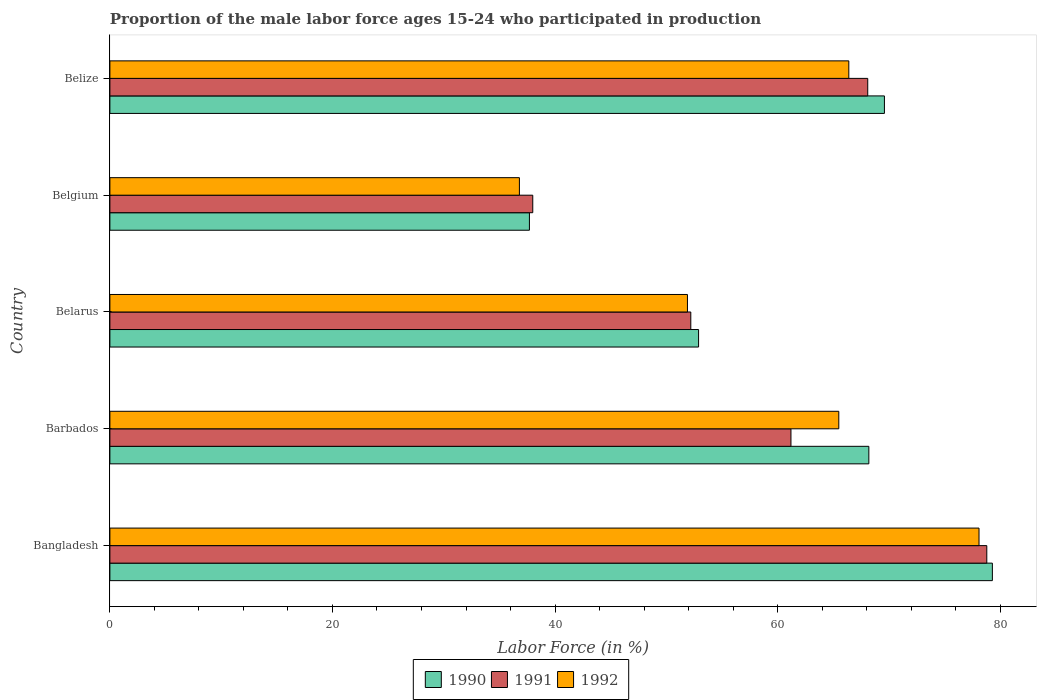How many different coloured bars are there?
Your response must be concise. 3. Are the number of bars per tick equal to the number of legend labels?
Provide a succinct answer. Yes. Are the number of bars on each tick of the Y-axis equal?
Provide a succinct answer. Yes. What is the label of the 3rd group of bars from the top?
Offer a terse response. Belarus. In how many cases, is the number of bars for a given country not equal to the number of legend labels?
Make the answer very short. 0. What is the proportion of the male labor force who participated in production in 1992 in Belize?
Your response must be concise. 66.4. Across all countries, what is the maximum proportion of the male labor force who participated in production in 1990?
Make the answer very short. 79.3. Across all countries, what is the minimum proportion of the male labor force who participated in production in 1991?
Give a very brief answer. 38. In which country was the proportion of the male labor force who participated in production in 1992 maximum?
Provide a succinct answer. Bangladesh. In which country was the proportion of the male labor force who participated in production in 1991 minimum?
Offer a very short reply. Belgium. What is the total proportion of the male labor force who participated in production in 1991 in the graph?
Provide a short and direct response. 298.3. What is the difference between the proportion of the male labor force who participated in production in 1991 in Belgium and that in Belize?
Offer a terse response. -30.1. What is the difference between the proportion of the male labor force who participated in production in 1991 in Bangladesh and the proportion of the male labor force who participated in production in 1990 in Belgium?
Keep it short and to the point. 41.1. What is the average proportion of the male labor force who participated in production in 1991 per country?
Your answer should be compact. 59.66. What is the difference between the proportion of the male labor force who participated in production in 1990 and proportion of the male labor force who participated in production in 1991 in Belgium?
Give a very brief answer. -0.3. In how many countries, is the proportion of the male labor force who participated in production in 1991 greater than 16 %?
Offer a very short reply. 5. What is the ratio of the proportion of the male labor force who participated in production in 1990 in Bangladesh to that in Barbados?
Give a very brief answer. 1.16. Is the proportion of the male labor force who participated in production in 1991 in Belgium less than that in Belize?
Ensure brevity in your answer.  Yes. What is the difference between the highest and the second highest proportion of the male labor force who participated in production in 1991?
Your answer should be compact. 10.7. What is the difference between the highest and the lowest proportion of the male labor force who participated in production in 1990?
Make the answer very short. 41.6. In how many countries, is the proportion of the male labor force who participated in production in 1991 greater than the average proportion of the male labor force who participated in production in 1991 taken over all countries?
Your response must be concise. 3. What does the 3rd bar from the bottom in Belize represents?
Provide a succinct answer. 1992. Is it the case that in every country, the sum of the proportion of the male labor force who participated in production in 1992 and proportion of the male labor force who participated in production in 1991 is greater than the proportion of the male labor force who participated in production in 1990?
Your response must be concise. Yes. How many bars are there?
Your response must be concise. 15. Are all the bars in the graph horizontal?
Make the answer very short. Yes. How many countries are there in the graph?
Give a very brief answer. 5. What is the difference between two consecutive major ticks on the X-axis?
Your answer should be very brief. 20. Are the values on the major ticks of X-axis written in scientific E-notation?
Keep it short and to the point. No. Does the graph contain any zero values?
Your answer should be very brief. No. Where does the legend appear in the graph?
Provide a succinct answer. Bottom center. What is the title of the graph?
Your answer should be very brief. Proportion of the male labor force ages 15-24 who participated in production. Does "1998" appear as one of the legend labels in the graph?
Give a very brief answer. No. What is the label or title of the Y-axis?
Offer a terse response. Country. What is the Labor Force (in %) in 1990 in Bangladesh?
Your answer should be compact. 79.3. What is the Labor Force (in %) in 1991 in Bangladesh?
Provide a succinct answer. 78.8. What is the Labor Force (in %) in 1992 in Bangladesh?
Your response must be concise. 78.1. What is the Labor Force (in %) of 1990 in Barbados?
Your answer should be compact. 68.2. What is the Labor Force (in %) in 1991 in Barbados?
Offer a terse response. 61.2. What is the Labor Force (in %) of 1992 in Barbados?
Your response must be concise. 65.5. What is the Labor Force (in %) in 1990 in Belarus?
Offer a terse response. 52.9. What is the Labor Force (in %) in 1991 in Belarus?
Give a very brief answer. 52.2. What is the Labor Force (in %) of 1992 in Belarus?
Ensure brevity in your answer.  51.9. What is the Labor Force (in %) in 1990 in Belgium?
Give a very brief answer. 37.7. What is the Labor Force (in %) in 1991 in Belgium?
Provide a short and direct response. 38. What is the Labor Force (in %) of 1992 in Belgium?
Offer a very short reply. 36.8. What is the Labor Force (in %) in 1990 in Belize?
Provide a succinct answer. 69.6. What is the Labor Force (in %) of 1991 in Belize?
Ensure brevity in your answer.  68.1. What is the Labor Force (in %) of 1992 in Belize?
Your response must be concise. 66.4. Across all countries, what is the maximum Labor Force (in %) of 1990?
Keep it short and to the point. 79.3. Across all countries, what is the maximum Labor Force (in %) in 1991?
Your answer should be very brief. 78.8. Across all countries, what is the maximum Labor Force (in %) of 1992?
Give a very brief answer. 78.1. Across all countries, what is the minimum Labor Force (in %) in 1990?
Keep it short and to the point. 37.7. Across all countries, what is the minimum Labor Force (in %) of 1992?
Your answer should be very brief. 36.8. What is the total Labor Force (in %) in 1990 in the graph?
Keep it short and to the point. 307.7. What is the total Labor Force (in %) in 1991 in the graph?
Offer a terse response. 298.3. What is the total Labor Force (in %) of 1992 in the graph?
Give a very brief answer. 298.7. What is the difference between the Labor Force (in %) in 1990 in Bangladesh and that in Belarus?
Your answer should be very brief. 26.4. What is the difference between the Labor Force (in %) of 1991 in Bangladesh and that in Belarus?
Make the answer very short. 26.6. What is the difference between the Labor Force (in %) in 1992 in Bangladesh and that in Belarus?
Keep it short and to the point. 26.2. What is the difference between the Labor Force (in %) in 1990 in Bangladesh and that in Belgium?
Give a very brief answer. 41.6. What is the difference between the Labor Force (in %) of 1991 in Bangladesh and that in Belgium?
Ensure brevity in your answer.  40.8. What is the difference between the Labor Force (in %) in 1992 in Bangladesh and that in Belgium?
Your answer should be compact. 41.3. What is the difference between the Labor Force (in %) of 1990 in Bangladesh and that in Belize?
Provide a succinct answer. 9.7. What is the difference between the Labor Force (in %) of 1992 in Bangladesh and that in Belize?
Your response must be concise. 11.7. What is the difference between the Labor Force (in %) of 1990 in Barbados and that in Belarus?
Provide a succinct answer. 15.3. What is the difference between the Labor Force (in %) in 1992 in Barbados and that in Belarus?
Your answer should be very brief. 13.6. What is the difference between the Labor Force (in %) of 1990 in Barbados and that in Belgium?
Offer a terse response. 30.5. What is the difference between the Labor Force (in %) in 1991 in Barbados and that in Belgium?
Provide a short and direct response. 23.2. What is the difference between the Labor Force (in %) of 1992 in Barbados and that in Belgium?
Keep it short and to the point. 28.7. What is the difference between the Labor Force (in %) of 1990 in Barbados and that in Belize?
Offer a very short reply. -1.4. What is the difference between the Labor Force (in %) in 1991 in Barbados and that in Belize?
Offer a terse response. -6.9. What is the difference between the Labor Force (in %) of 1992 in Barbados and that in Belize?
Your answer should be very brief. -0.9. What is the difference between the Labor Force (in %) in 1990 in Belarus and that in Belgium?
Ensure brevity in your answer.  15.2. What is the difference between the Labor Force (in %) of 1990 in Belarus and that in Belize?
Ensure brevity in your answer.  -16.7. What is the difference between the Labor Force (in %) in 1991 in Belarus and that in Belize?
Ensure brevity in your answer.  -15.9. What is the difference between the Labor Force (in %) of 1992 in Belarus and that in Belize?
Your answer should be very brief. -14.5. What is the difference between the Labor Force (in %) in 1990 in Belgium and that in Belize?
Provide a succinct answer. -31.9. What is the difference between the Labor Force (in %) of 1991 in Belgium and that in Belize?
Offer a very short reply. -30.1. What is the difference between the Labor Force (in %) of 1992 in Belgium and that in Belize?
Offer a very short reply. -29.6. What is the difference between the Labor Force (in %) of 1990 in Bangladesh and the Labor Force (in %) of 1991 in Barbados?
Ensure brevity in your answer.  18.1. What is the difference between the Labor Force (in %) of 1991 in Bangladesh and the Labor Force (in %) of 1992 in Barbados?
Provide a short and direct response. 13.3. What is the difference between the Labor Force (in %) in 1990 in Bangladesh and the Labor Force (in %) in 1991 in Belarus?
Ensure brevity in your answer.  27.1. What is the difference between the Labor Force (in %) of 1990 in Bangladesh and the Labor Force (in %) of 1992 in Belarus?
Offer a very short reply. 27.4. What is the difference between the Labor Force (in %) in 1991 in Bangladesh and the Labor Force (in %) in 1992 in Belarus?
Provide a succinct answer. 26.9. What is the difference between the Labor Force (in %) in 1990 in Bangladesh and the Labor Force (in %) in 1991 in Belgium?
Ensure brevity in your answer.  41.3. What is the difference between the Labor Force (in %) in 1990 in Bangladesh and the Labor Force (in %) in 1992 in Belgium?
Offer a terse response. 42.5. What is the difference between the Labor Force (in %) in 1990 in Bangladesh and the Labor Force (in %) in 1991 in Belize?
Ensure brevity in your answer.  11.2. What is the difference between the Labor Force (in %) of 1990 in Bangladesh and the Labor Force (in %) of 1992 in Belize?
Make the answer very short. 12.9. What is the difference between the Labor Force (in %) in 1991 in Bangladesh and the Labor Force (in %) in 1992 in Belize?
Ensure brevity in your answer.  12.4. What is the difference between the Labor Force (in %) in 1990 in Barbados and the Labor Force (in %) in 1992 in Belarus?
Your answer should be very brief. 16.3. What is the difference between the Labor Force (in %) of 1990 in Barbados and the Labor Force (in %) of 1991 in Belgium?
Make the answer very short. 30.2. What is the difference between the Labor Force (in %) of 1990 in Barbados and the Labor Force (in %) of 1992 in Belgium?
Your answer should be very brief. 31.4. What is the difference between the Labor Force (in %) of 1991 in Barbados and the Labor Force (in %) of 1992 in Belgium?
Make the answer very short. 24.4. What is the difference between the Labor Force (in %) of 1990 in Barbados and the Labor Force (in %) of 1991 in Belize?
Ensure brevity in your answer.  0.1. What is the difference between the Labor Force (in %) of 1990 in Belarus and the Labor Force (in %) of 1992 in Belgium?
Provide a succinct answer. 16.1. What is the difference between the Labor Force (in %) of 1990 in Belarus and the Labor Force (in %) of 1991 in Belize?
Provide a succinct answer. -15.2. What is the difference between the Labor Force (in %) in 1990 in Belarus and the Labor Force (in %) in 1992 in Belize?
Keep it short and to the point. -13.5. What is the difference between the Labor Force (in %) in 1990 in Belgium and the Labor Force (in %) in 1991 in Belize?
Ensure brevity in your answer.  -30.4. What is the difference between the Labor Force (in %) of 1990 in Belgium and the Labor Force (in %) of 1992 in Belize?
Give a very brief answer. -28.7. What is the difference between the Labor Force (in %) of 1991 in Belgium and the Labor Force (in %) of 1992 in Belize?
Provide a short and direct response. -28.4. What is the average Labor Force (in %) in 1990 per country?
Provide a short and direct response. 61.54. What is the average Labor Force (in %) of 1991 per country?
Make the answer very short. 59.66. What is the average Labor Force (in %) in 1992 per country?
Offer a very short reply. 59.74. What is the difference between the Labor Force (in %) of 1990 and Labor Force (in %) of 1991 in Bangladesh?
Provide a short and direct response. 0.5. What is the difference between the Labor Force (in %) in 1991 and Labor Force (in %) in 1992 in Barbados?
Your response must be concise. -4.3. What is the difference between the Labor Force (in %) of 1990 and Labor Force (in %) of 1991 in Belarus?
Your answer should be very brief. 0.7. What is the difference between the Labor Force (in %) of 1990 and Labor Force (in %) of 1992 in Belarus?
Keep it short and to the point. 1. What is the difference between the Labor Force (in %) in 1991 and Labor Force (in %) in 1992 in Belarus?
Your answer should be compact. 0.3. What is the difference between the Labor Force (in %) of 1990 and Labor Force (in %) of 1991 in Belgium?
Your answer should be very brief. -0.3. What is the difference between the Labor Force (in %) of 1990 and Labor Force (in %) of 1992 in Belize?
Provide a short and direct response. 3.2. What is the ratio of the Labor Force (in %) of 1990 in Bangladesh to that in Barbados?
Ensure brevity in your answer.  1.16. What is the ratio of the Labor Force (in %) of 1991 in Bangladesh to that in Barbados?
Give a very brief answer. 1.29. What is the ratio of the Labor Force (in %) of 1992 in Bangladesh to that in Barbados?
Your answer should be very brief. 1.19. What is the ratio of the Labor Force (in %) of 1990 in Bangladesh to that in Belarus?
Provide a succinct answer. 1.5. What is the ratio of the Labor Force (in %) of 1991 in Bangladesh to that in Belarus?
Your response must be concise. 1.51. What is the ratio of the Labor Force (in %) of 1992 in Bangladesh to that in Belarus?
Your answer should be compact. 1.5. What is the ratio of the Labor Force (in %) of 1990 in Bangladesh to that in Belgium?
Make the answer very short. 2.1. What is the ratio of the Labor Force (in %) of 1991 in Bangladesh to that in Belgium?
Provide a succinct answer. 2.07. What is the ratio of the Labor Force (in %) of 1992 in Bangladesh to that in Belgium?
Provide a short and direct response. 2.12. What is the ratio of the Labor Force (in %) of 1990 in Bangladesh to that in Belize?
Keep it short and to the point. 1.14. What is the ratio of the Labor Force (in %) in 1991 in Bangladesh to that in Belize?
Provide a succinct answer. 1.16. What is the ratio of the Labor Force (in %) in 1992 in Bangladesh to that in Belize?
Offer a terse response. 1.18. What is the ratio of the Labor Force (in %) of 1990 in Barbados to that in Belarus?
Give a very brief answer. 1.29. What is the ratio of the Labor Force (in %) in 1991 in Barbados to that in Belarus?
Provide a succinct answer. 1.17. What is the ratio of the Labor Force (in %) in 1992 in Barbados to that in Belarus?
Provide a short and direct response. 1.26. What is the ratio of the Labor Force (in %) in 1990 in Barbados to that in Belgium?
Keep it short and to the point. 1.81. What is the ratio of the Labor Force (in %) of 1991 in Barbados to that in Belgium?
Offer a very short reply. 1.61. What is the ratio of the Labor Force (in %) in 1992 in Barbados to that in Belgium?
Offer a terse response. 1.78. What is the ratio of the Labor Force (in %) in 1990 in Barbados to that in Belize?
Provide a succinct answer. 0.98. What is the ratio of the Labor Force (in %) in 1991 in Barbados to that in Belize?
Your answer should be very brief. 0.9. What is the ratio of the Labor Force (in %) of 1992 in Barbados to that in Belize?
Make the answer very short. 0.99. What is the ratio of the Labor Force (in %) of 1990 in Belarus to that in Belgium?
Your response must be concise. 1.4. What is the ratio of the Labor Force (in %) of 1991 in Belarus to that in Belgium?
Make the answer very short. 1.37. What is the ratio of the Labor Force (in %) in 1992 in Belarus to that in Belgium?
Provide a short and direct response. 1.41. What is the ratio of the Labor Force (in %) in 1990 in Belarus to that in Belize?
Keep it short and to the point. 0.76. What is the ratio of the Labor Force (in %) of 1991 in Belarus to that in Belize?
Give a very brief answer. 0.77. What is the ratio of the Labor Force (in %) in 1992 in Belarus to that in Belize?
Make the answer very short. 0.78. What is the ratio of the Labor Force (in %) of 1990 in Belgium to that in Belize?
Offer a very short reply. 0.54. What is the ratio of the Labor Force (in %) of 1991 in Belgium to that in Belize?
Give a very brief answer. 0.56. What is the ratio of the Labor Force (in %) in 1992 in Belgium to that in Belize?
Give a very brief answer. 0.55. What is the difference between the highest and the second highest Labor Force (in %) in 1991?
Your answer should be very brief. 10.7. What is the difference between the highest and the lowest Labor Force (in %) in 1990?
Ensure brevity in your answer.  41.6. What is the difference between the highest and the lowest Labor Force (in %) in 1991?
Your response must be concise. 40.8. What is the difference between the highest and the lowest Labor Force (in %) of 1992?
Your answer should be very brief. 41.3. 